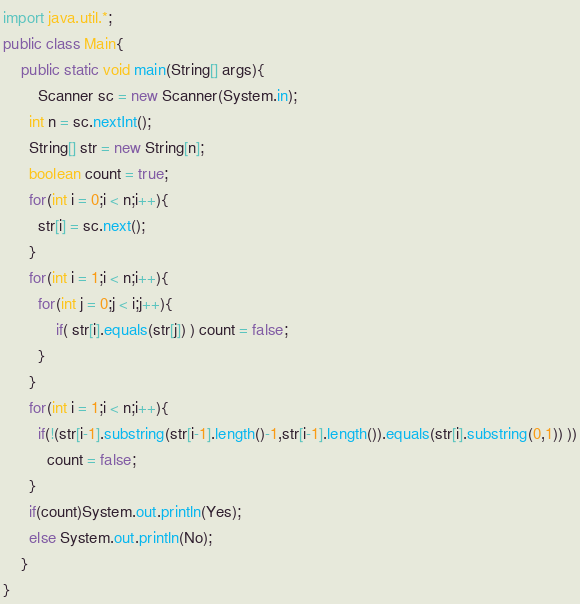<code> <loc_0><loc_0><loc_500><loc_500><_Java_>import java.util.*;
public class Main{
	public static void main(String[] args){
    	Scanner sc = new Scanner(System.in);
      int n = sc.nextInt();
      String[] str = new String[n];
      boolean count = true;
      for(int i = 0;i < n;i++){
      	str[i] = sc.next();
      }
      for(int i = 1;i < n;i++){
      	for(int j = 0;j < i;j++){
        	if( str[i].equals(str[j]) ) count = false;
        }
      }
      for(int i = 1;i < n;i++){
      	if(!(str[i-1].substring(str[i-1].length()-1,str[i-1].length()).equals(str[i].substring(0,1)) ))
          count = false;
      }
      if(count)System.out.println(Yes);
      else System.out.println(No);
    }
}</code> 